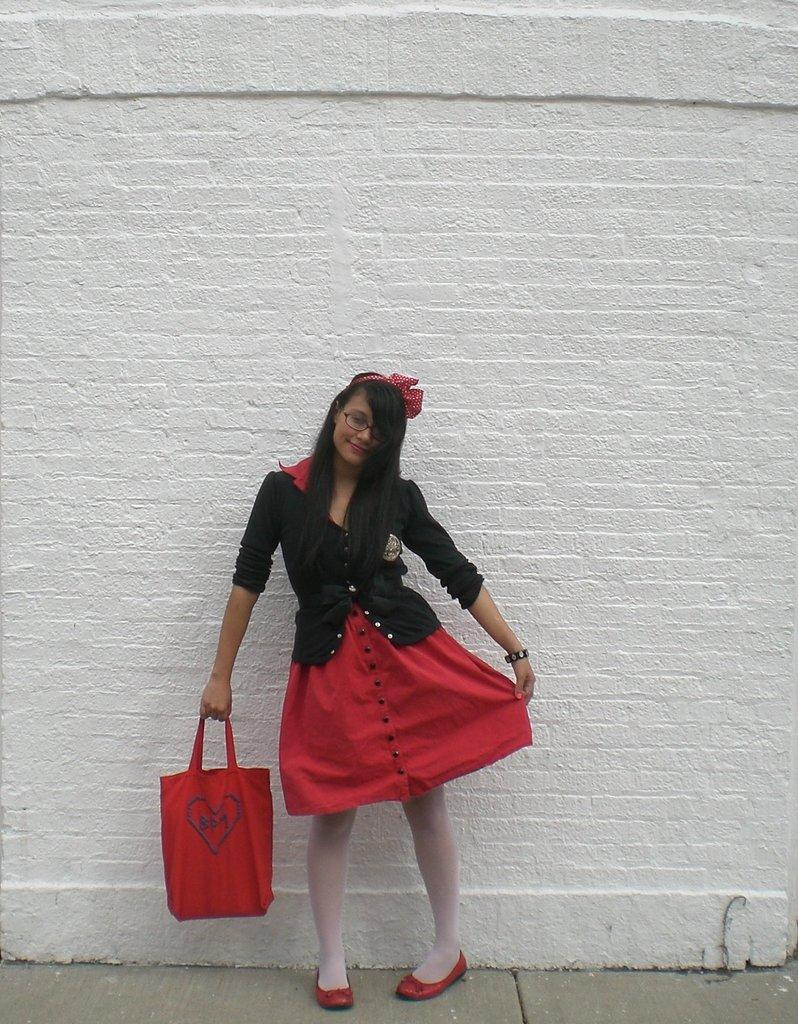Who is the main subject in the image? There is a lady in the image. What accessory is the lady wearing on her face? The lady is wearing specs. What type of hair accessory is the lady wearing? The lady is wearing a hair band. What is the lady holding in the image? The lady is holding a bag. What can be seen in the background of the image? There is a brick wall in the background of the image. What type of frogs can be seen hopping around the lady in the image? There are no frogs present in the image. What type of quince dish is the lady preparing in the image? There is no quince dish or any food preparation visible in the image. 